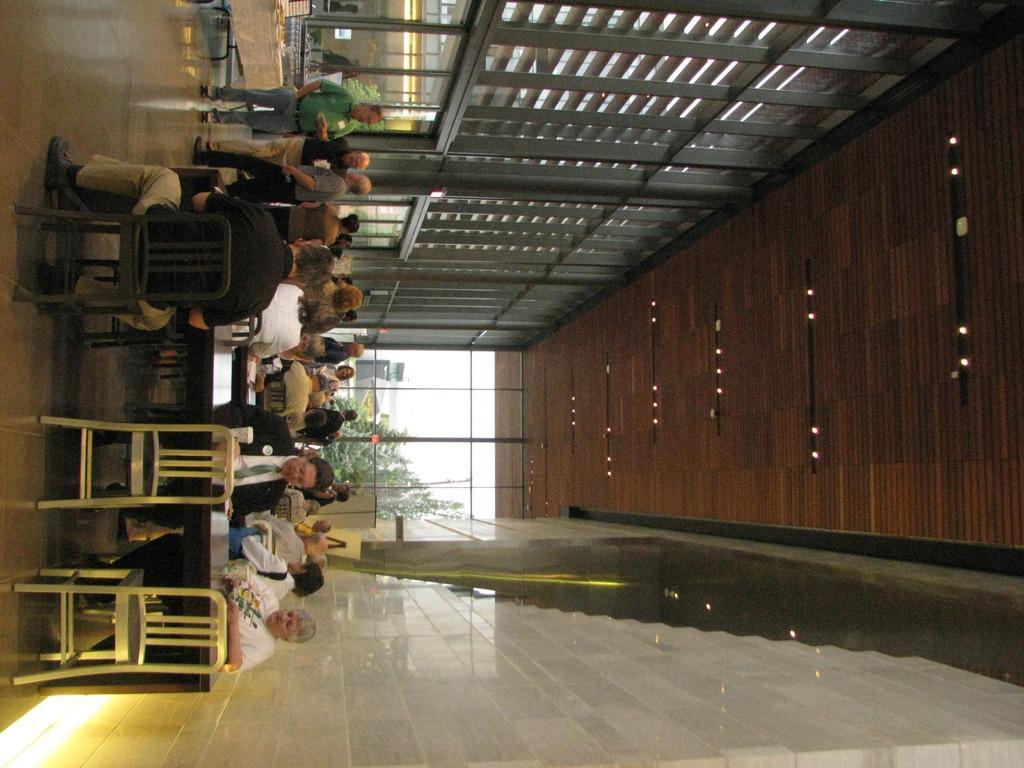Describe this image in one or two sentences. In the image on the left side there are chairs, tables and also there are people. At the back of them there are glass door. And at the bottom there is a wall with tiles. On the right side of the image there is a brown color roof with lights. At the top of the image there are rods and pillars. 